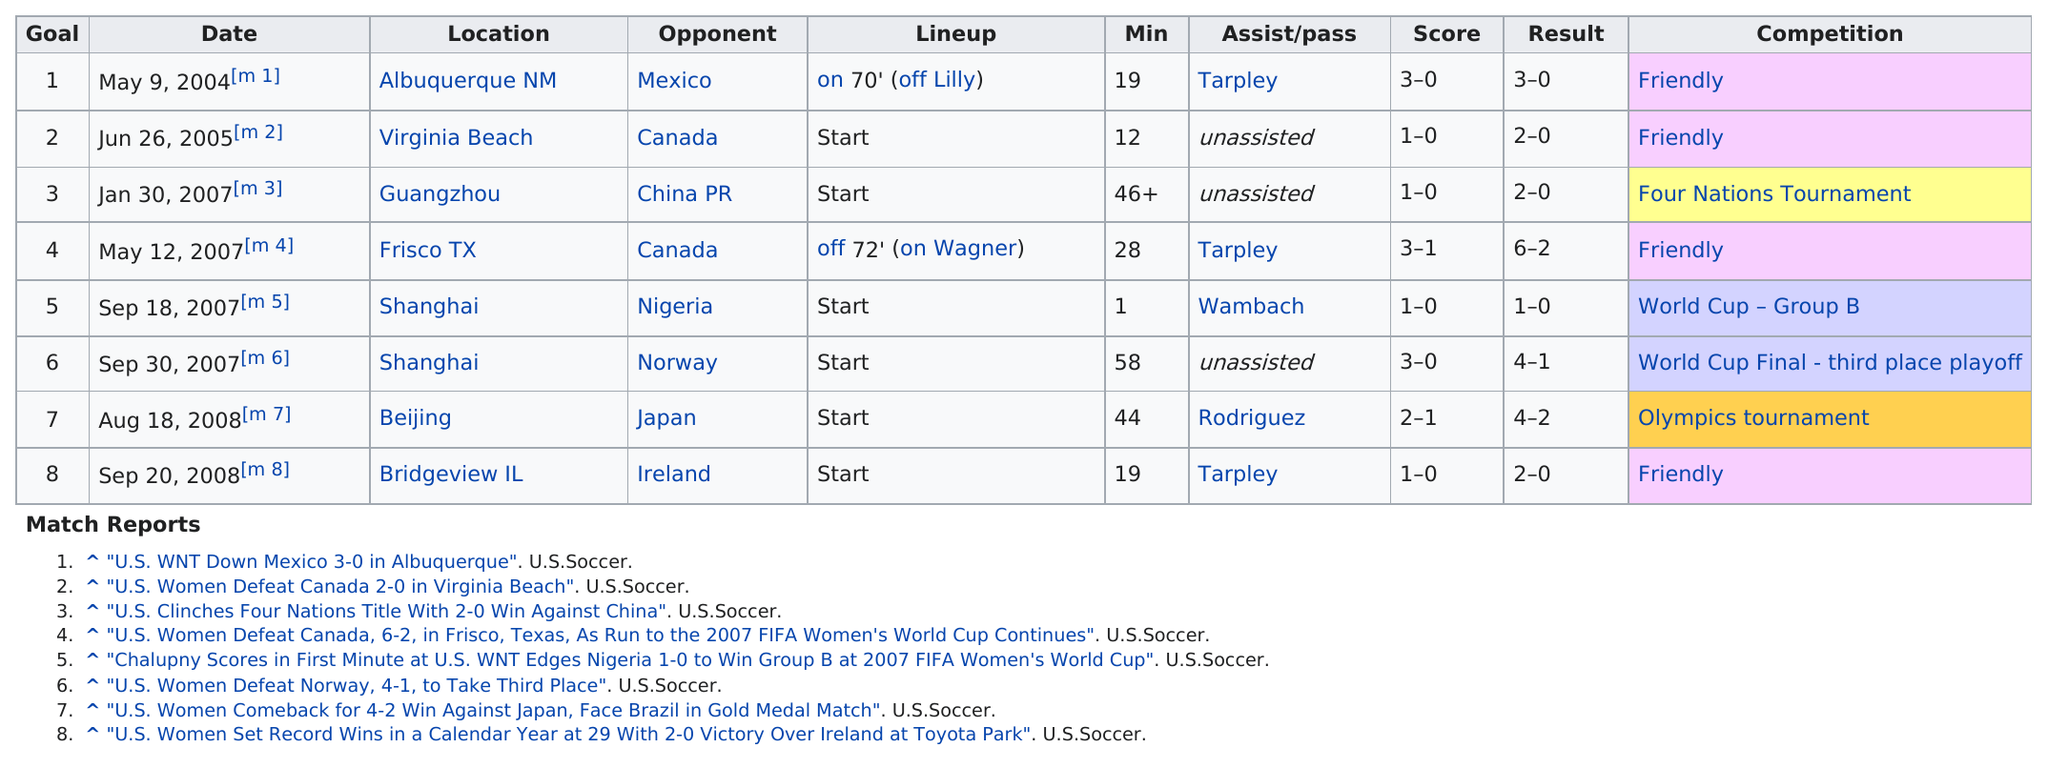Give some essential details in this illustration. The opponent that faced Mexico when the first goal was scored in 2004 was not specified. The first goal in the game was scored at minute 19. Only Nigeria was able to score against Wambach, with the help of her opponent. In total, how many goals were scored against Nigeria? The last location on the chart is Bridgeview, Illinois. 